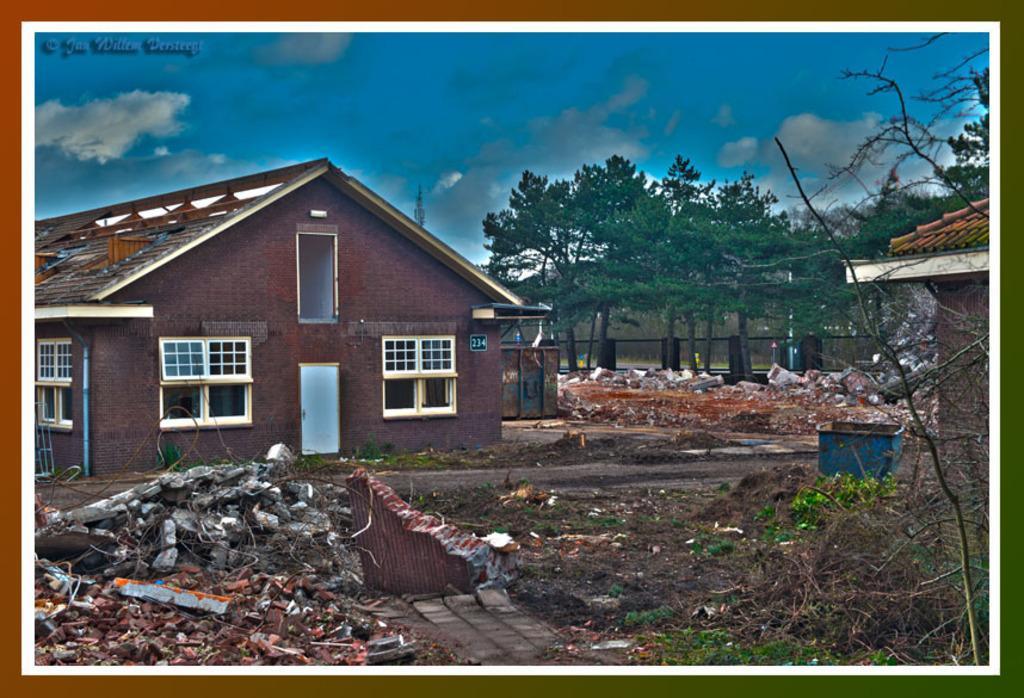Describe this image in one or two sentences. In this image, we can see poster. In this poster, we can see houses, walls, windows, door, trees, railing, planter, trash and few objects. In the background, there is the cloudy sky. In the top left side of the image, there is a watermark. 